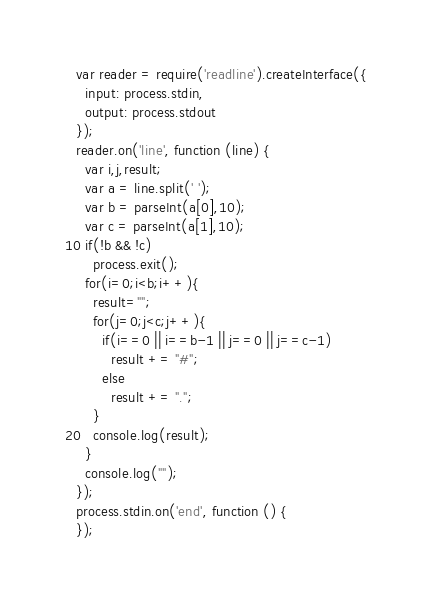Convert code to text. <code><loc_0><loc_0><loc_500><loc_500><_JavaScript_>var reader = require('readline').createInterface({
  input: process.stdin,
  output: process.stdout
});
reader.on('line', function (line) {
  var i,j,result;
  var a = line.split(' ');
  var b = parseInt(a[0],10);
  var c = parseInt(a[1],10);
  if(!b && !c)
    process.exit();
  for(i=0;i<b;i++){
    result="";
    for(j=0;j<c;j++){
      if(i==0 || i==b-1 || j==0 || j==c-1)
        result += "#";
      else
        result += ".";
    }
    console.log(result);
  }
  console.log("");
});
process.stdin.on('end', function () {
});</code> 